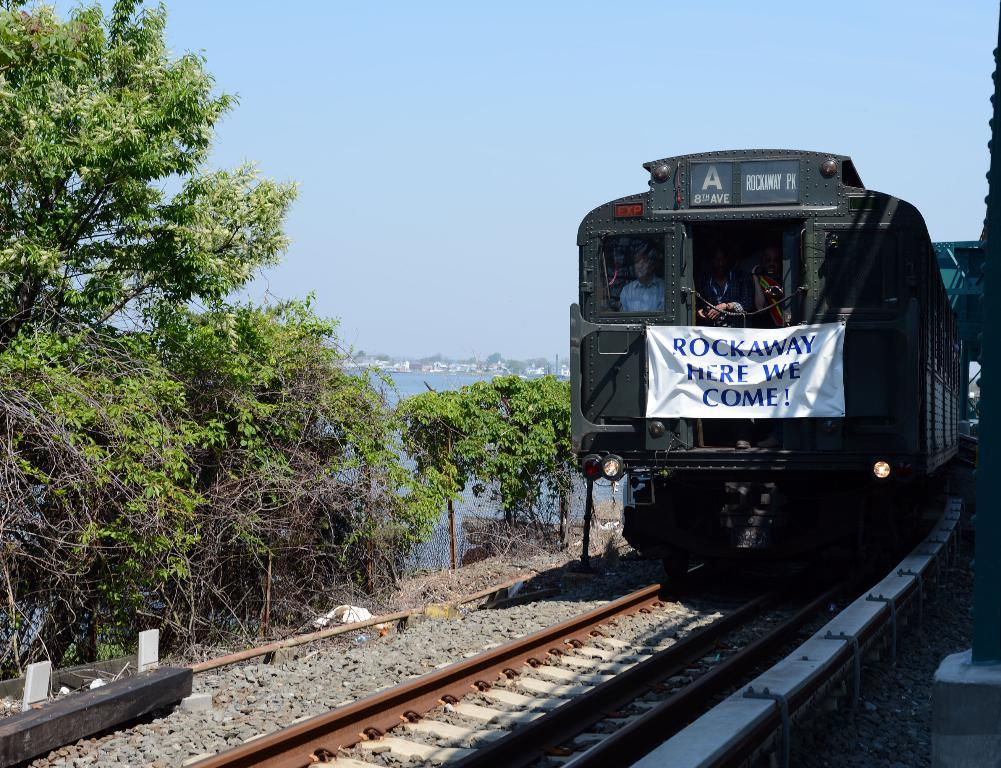<image>
Create a compact narrative representing the image presented. A train driving on some tracks next to water that reads ROCKAWAY HERE WE COME. 